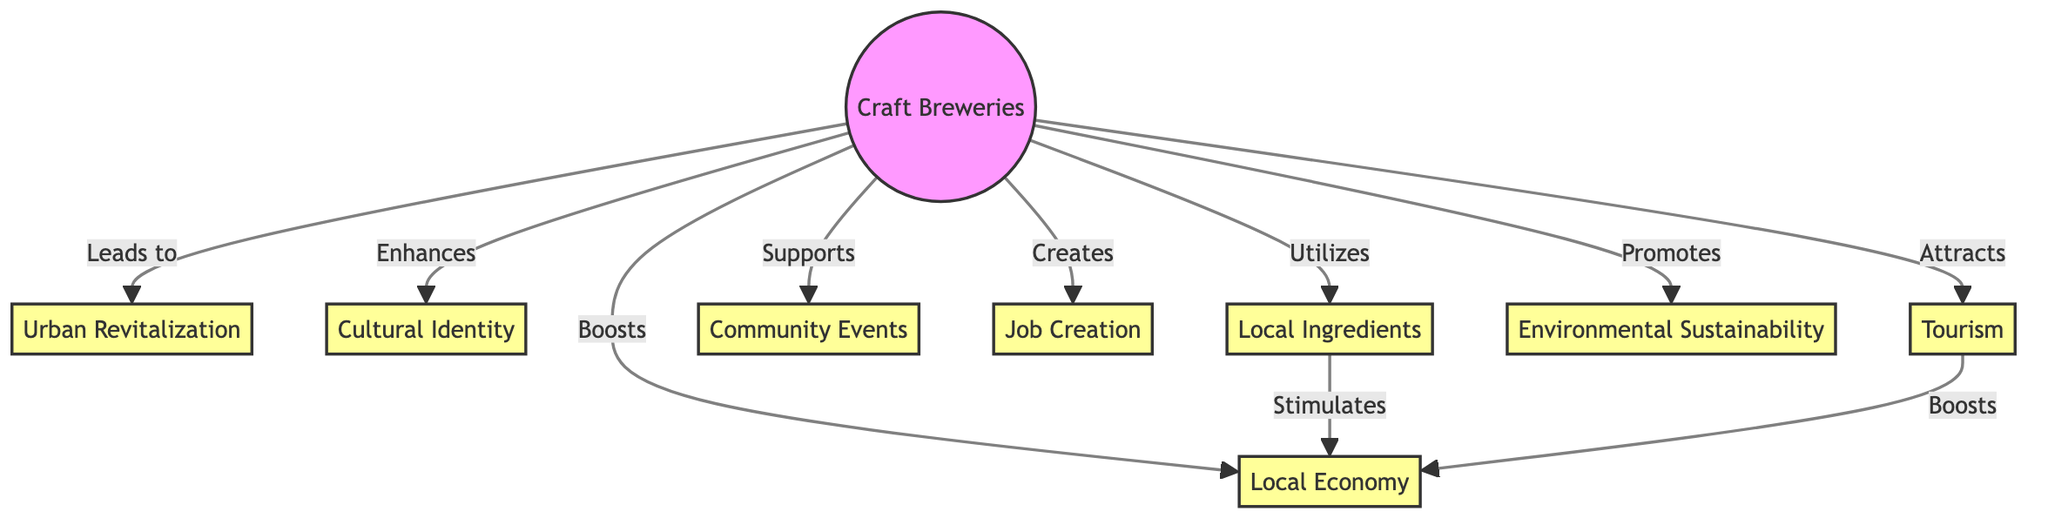What is the central node in the diagram? The central node represents "Craft Breweries," which is the primary focus from which all other influences and trends arise.
Answer: Craft Breweries How many impact nodes are there in total? There are eight impact nodes connected to the central node, which represent various aspects influenced by craft breweries.
Answer: 8 Which impact node is directly related to "Job Creation"? The impact node "Job Creation" is directly connected to the central node "Craft Breweries," indicating a direct relationship.
Answer: Craft Breweries What type of influence do "Craft Breweries" have on "Tourism"? The influence is labeled as “Attracts,” indicating that craft breweries actively draw tourists to urban communities.
Answer: Attracts Which node is a source for "Local Economy"? "Local Ingredients" is indicated as a source that stimulates the "Local Economy," showing a direct relationship in the diagram.
Answer: Local Ingredients What are the relationships between "Craft Breweries" and "Environmental Sustainability"? The relationship is labeled as “Promotes,” suggesting that craft breweries actively encourage practices related to environmental sustainability.
Answer: Promotes What node is linked to both "Local Economy" and "Tourism"? The node "Local Economy" is linked to "Tourism" through the influences of both "Craft Breweries" and the direct boost from tourism activities.
Answer: Local Economy How many nodes are there that relate to community engagement? The nodes related to community engagement are "Community Events" and "Job Creation," totaling two connections focused on community interaction and development.
Answer: 2 What is the relationship between "Local Ingredients" and "Local Economy"? The relationship is described as “Stimulates,” meaning that the use of local ingredients by craft breweries enhances the local economy's growth.
Answer: Stimulates 